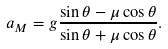<formula> <loc_0><loc_0><loc_500><loc_500>a _ { M } = g \frac { \sin \theta - \mu \cos \theta } { \sin \theta + \mu \cos \theta } .</formula> 